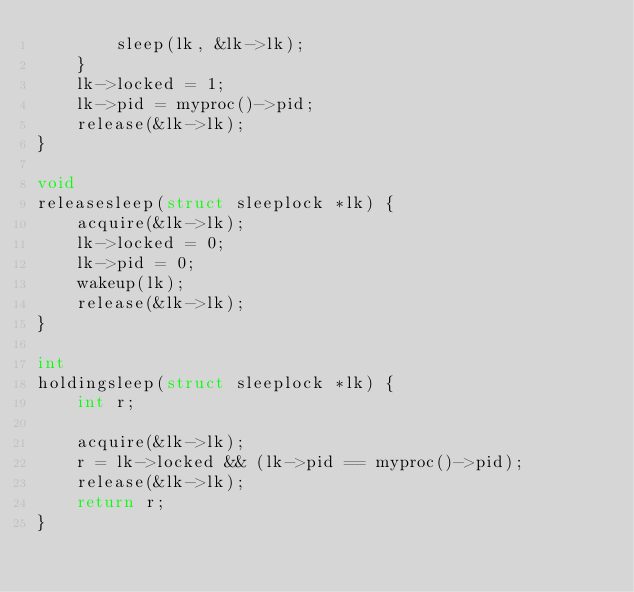<code> <loc_0><loc_0><loc_500><loc_500><_C_>        sleep(lk, &lk->lk);
    }
    lk->locked = 1;
    lk->pid = myproc()->pid;
    release(&lk->lk);
}

void
releasesleep(struct sleeplock *lk) {
    acquire(&lk->lk);
    lk->locked = 0;
    lk->pid = 0;
    wakeup(lk);
    release(&lk->lk);
}

int
holdingsleep(struct sleeplock *lk) {
    int r;

    acquire(&lk->lk);
    r = lk->locked && (lk->pid == myproc()->pid);
    release(&lk->lk);
    return r;
}



</code> 